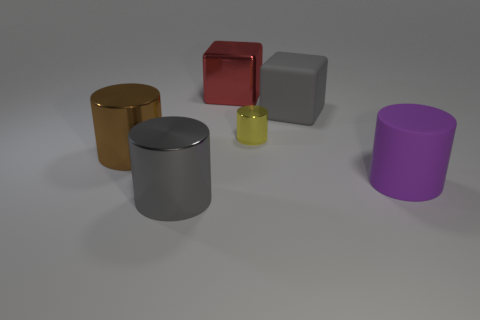What can you infer about the lighting of the scene based on the shadows visible? It seems that the light source is coming from the top left, as indicated by the shadows being cast diagonally towards the bottom right. The shadows suggest that the light source is not overly direct, given their soft edges. 